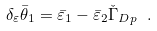<formula> <loc_0><loc_0><loc_500><loc_500>\delta _ { \varepsilon } \bar { \theta } _ { 1 } = \bar { \varepsilon } _ { 1 } - \bar { \varepsilon } _ { 2 } \check { \Gamma } _ { D p } \ .</formula> 